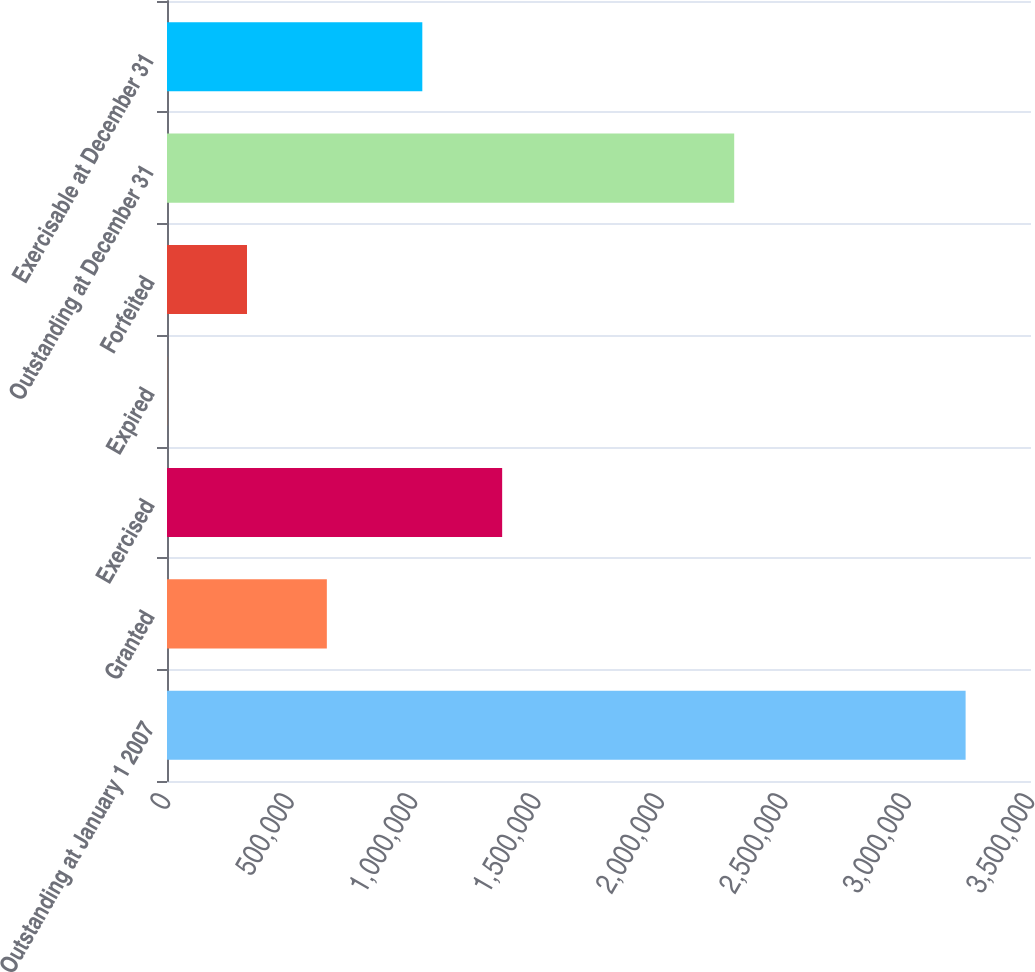Convert chart to OTSL. <chart><loc_0><loc_0><loc_500><loc_500><bar_chart><fcel>Outstanding at January 1 2007<fcel>Granted<fcel>Exercised<fcel>Expired<fcel>Forfeited<fcel>Outstanding at December 31<fcel>Exercisable at December 31<nl><fcel>3.2351e+06<fcel>647500<fcel>1.35771e+06<fcel>600<fcel>324050<fcel>2.29772e+06<fcel>1.03426e+06<nl></chart> 